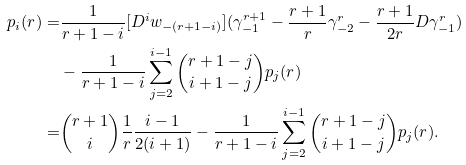Convert formula to latex. <formula><loc_0><loc_0><loc_500><loc_500>p _ { i } ( r ) = & \frac { 1 } { r + 1 - i } [ D ^ { i } w _ { - ( r + 1 - i ) } ] ( \gamma _ { - 1 } ^ { r + 1 } - \frac { r + 1 } { r } \gamma _ { - 2 } ^ { r } - \frac { r + 1 } { 2 r } D \gamma _ { - 1 } ^ { r } ) \\ & - \frac { 1 } { r + 1 - i } \sum _ { j = 2 } ^ { i - 1 } \binom { r + 1 - j } { i + 1 - j } p _ { j } ( r ) \\ = & \binom { r + 1 } { i } \frac { 1 } { r } \frac { i - 1 } { 2 ( i + 1 ) } - \frac { 1 } { r + 1 - i } \sum _ { j = 2 } ^ { i - 1 } \binom { r + 1 - j } { i + 1 - j } p _ { j } ( r ) .</formula> 